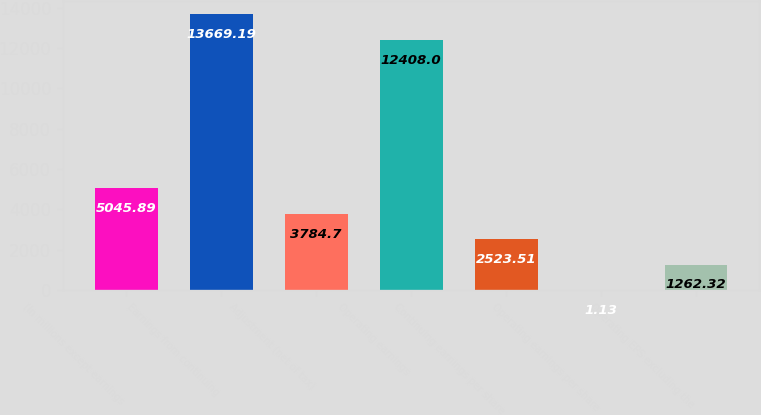Convert chart to OTSL. <chart><loc_0><loc_0><loc_500><loc_500><bar_chart><fcel>(In millions except earnings<fcel>Earnings from continuing<fcel>Adjustment (net of tax)<fcel>Operating earnings<fcel>Continuing earnings per share<fcel>Operating earnings per share<fcel>Operating EPS excluding the<nl><fcel>5045.89<fcel>13669.2<fcel>3784.7<fcel>12408<fcel>2523.51<fcel>1.13<fcel>1262.32<nl></chart> 